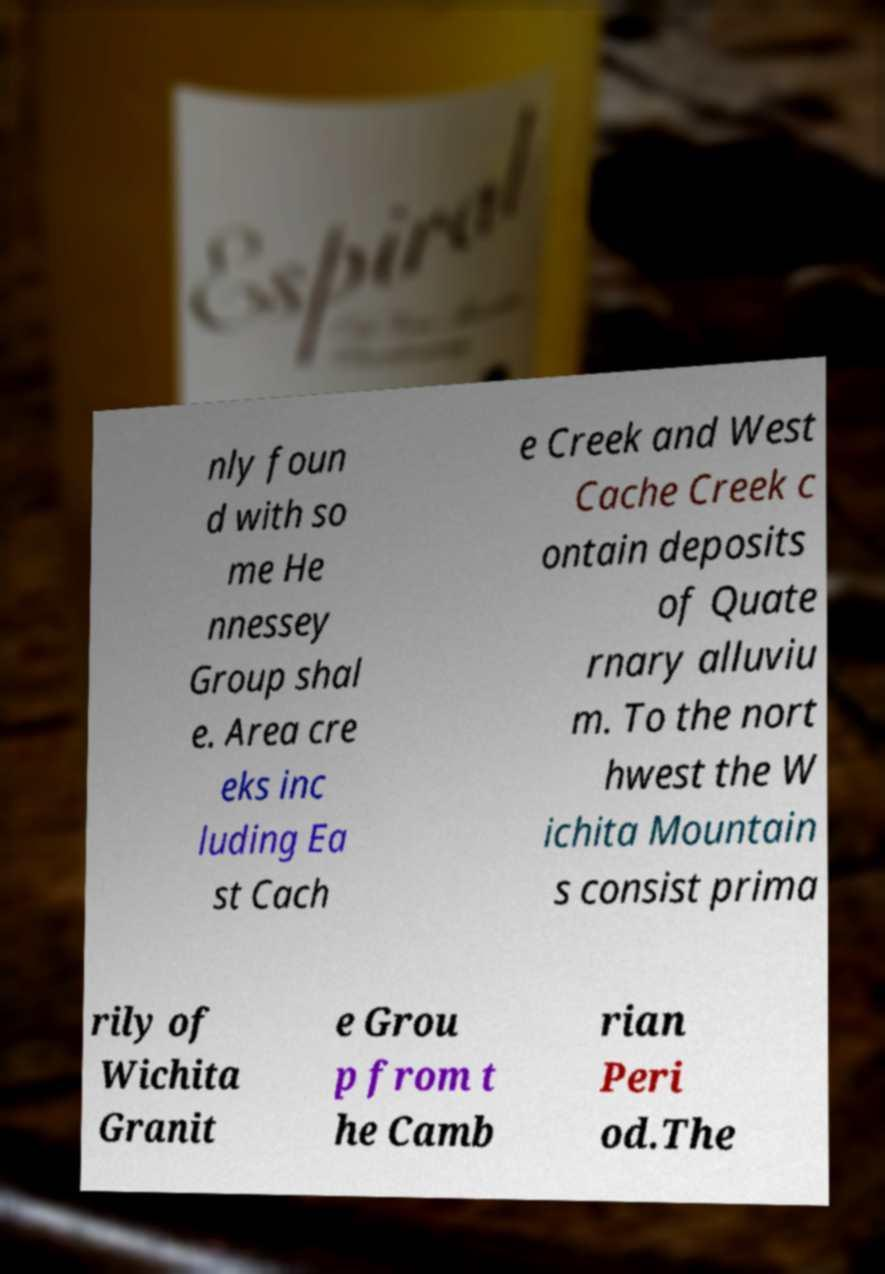Can you accurately transcribe the text from the provided image for me? nly foun d with so me He nnessey Group shal e. Area cre eks inc luding Ea st Cach e Creek and West Cache Creek c ontain deposits of Quate rnary alluviu m. To the nort hwest the W ichita Mountain s consist prima rily of Wichita Granit e Grou p from t he Camb rian Peri od.The 